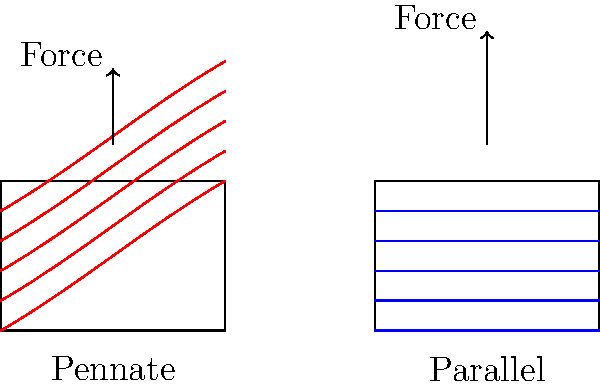Based on the muscle fiber arrangements shown in the diagram, which type of muscle architecture would likely produce greater maximum force but have a reduced range of motion? Explain the trade-off between force production and range of motion in relation to these muscle fiber arrangements. To answer this question, let's analyze the two muscle fiber arrangements shown in the diagram:

1. Pennate arrangement (left):
   - Fibers are arranged at an angle to the line of action of the muscle.
   - This allows for more fibers to be packed into a given volume.
   - The force generated by each fiber is not directly in line with the overall muscle action.

2. Parallel arrangement (right):
   - Fibers are arranged parallel to the line of action of the muscle.
   - Fewer fibers can fit into the same volume compared to the pennate arrangement.
   - The force generated by each fiber is directly in line with the overall muscle action.

Force production:
- Pennate muscles can generate greater maximum force due to their ability to pack more fibers into a given volume. This is represented by the equation:

   $$F_{total} = F_{fiber} \times N_{fibers} \times \cos(\theta)$$

   Where $F_{total}$ is the total force, $F_{fiber}$ is the force per fiber, $N_{fibers}$ is the number of fibers, and $\theta$ is the angle of pennation.

Range of motion:
- Parallel muscles typically have a greater range of motion because their fibers can shorten over a longer distance.
- Pennate muscles have a reduced range of motion due to their angled arrangement, which limits the overall shortening distance.

The trade-off:
- Pennate muscles sacrifice some range of motion for increased force production.
- This trade-off is beneficial in situations where high force output is more important than a large range of motion (e.g., postural muscles, certain leg muscles for powerful jumps).
- Parallel muscles offer a greater range of motion but may not achieve the same maximum force as pennate muscles of the same volume.

In the diagram, the shorter force vector for the pennate arrangement illustrates the reduced range of motion, while the greater number of fibers suggests higher force production capability.
Answer: Pennate muscle architecture 